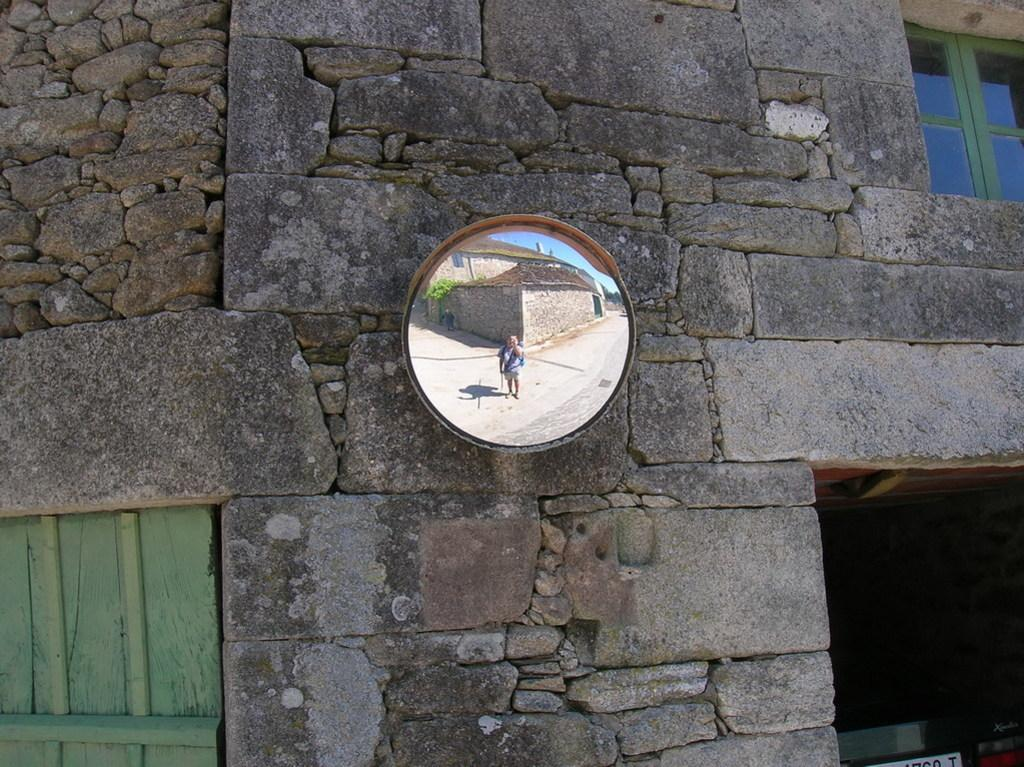What is on the wall in the image? There is a mirror on the wall in the image. What is located next to the mirror? There is a window next to the mirror in the image. What can be seen in the mirror? There is a person's reflection in the mirror. What is visible behind the person in the mirror? Buildings are visible behind the person in the mirror. How many knives are on the table in the image? There is no table or knives present in the image. How many boys are visible in the mirror? There are no boys visible in the mirror; only a person's reflection is present. 